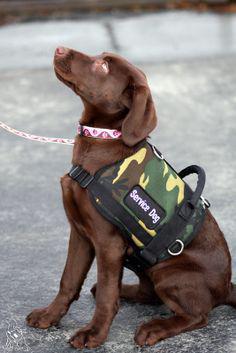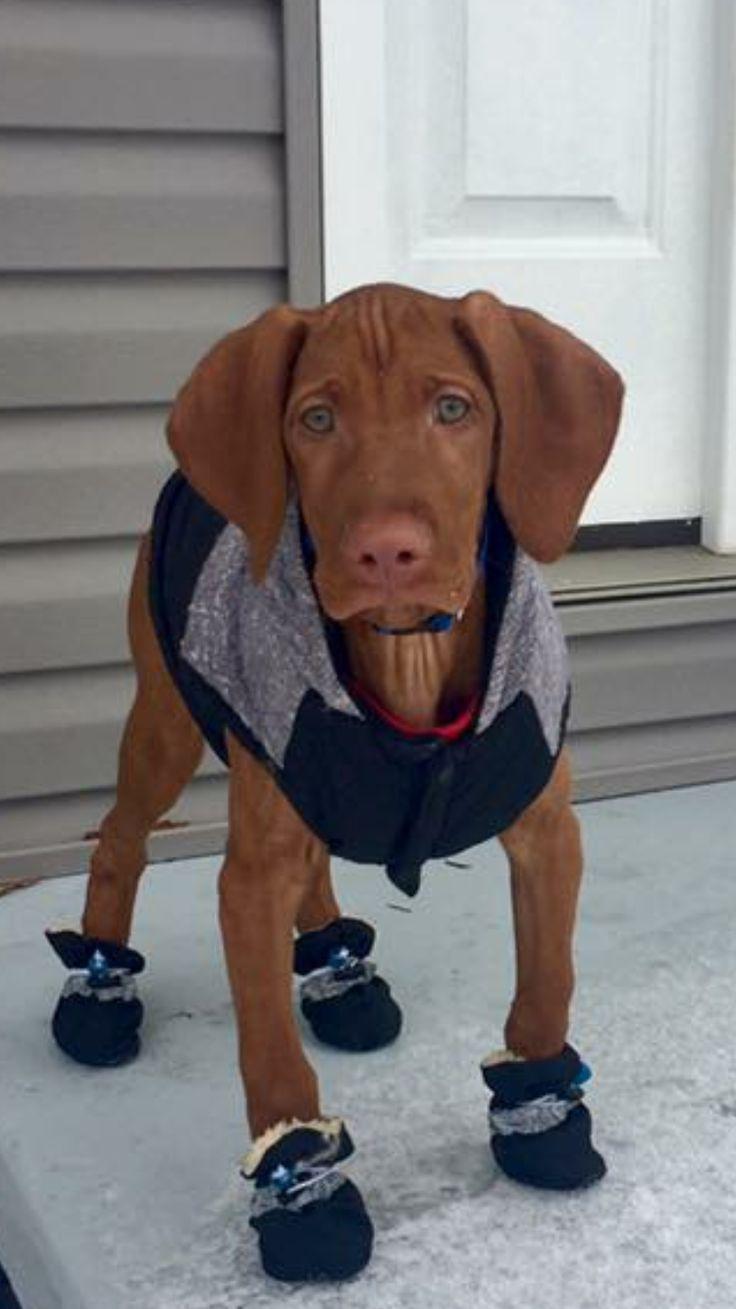The first image is the image on the left, the second image is the image on the right. For the images shown, is this caption "One dog is wearing a sweater." true? Answer yes or no. Yes. The first image is the image on the left, the second image is the image on the right. Examine the images to the left and right. Is the description "One image shows a dog wearing a harness and the other shows a dog wearing a shirt." accurate? Answer yes or no. Yes. 